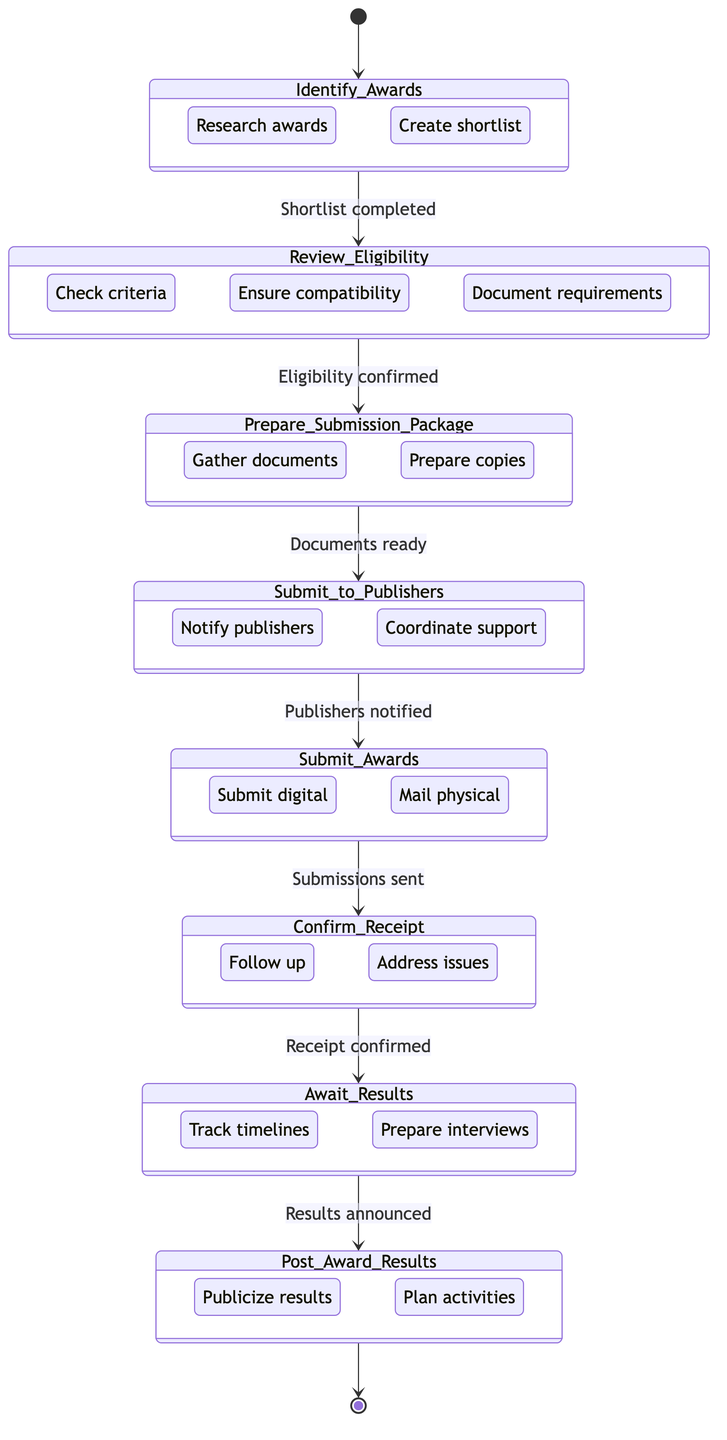What is the first state in the diagram? The first state, indicated by the initial transition from the starting point, is "Identify_Awards."
Answer: Identify_Awards How many states are present in the diagram? Counting all distinct states in the diagram, there are eight states from "Identify_Awards" to "Post_Award_Results."
Answer: 8 What triggers the transition from "Review_Eligibility" to "Prepare_Submission_Package"? The transition occurs when the eligibility criteria are confirmed, as indicated in the diagram.
Answer: Eligibility criteria confirmed Which state follows "Submit_to_Publishers"? The state directly after "Submit_to_Publishers" is "Submit_Awards," as shown by the transition connection.
Answer: Submit_Awards What action is first taken within the "Prepare_Submission_Package" state? The first action in this state is to gather necessary documents as detailed in the actions list.
Answer: Gather necessary documents How does one move from "Await_Results" to "Post_Award_Results"? The transition to "Post_Award_Results" takes place when the award results are announced, as indicated by the triggering condition in the diagram.
Answer: Award results announced What is the last state before the completion of the process? The last state that leads to completion in the diagram is "Post_Award_Results," which concludes the submission process.
Answer: Post_Award_Results What commonality exists between "Submit_Awards" and "Confirm_Receipt"? Both states involve actions related to the submission process, specifically the submission being sent and confirming receipt thereafter.
Answer: Submission process What must be completed before "Preparing Submission Package" can occur? Completing the review of eligibility criteria is essential prior to moving on to preparing the submission package.
Answer: Eligibility criteria confirmed 